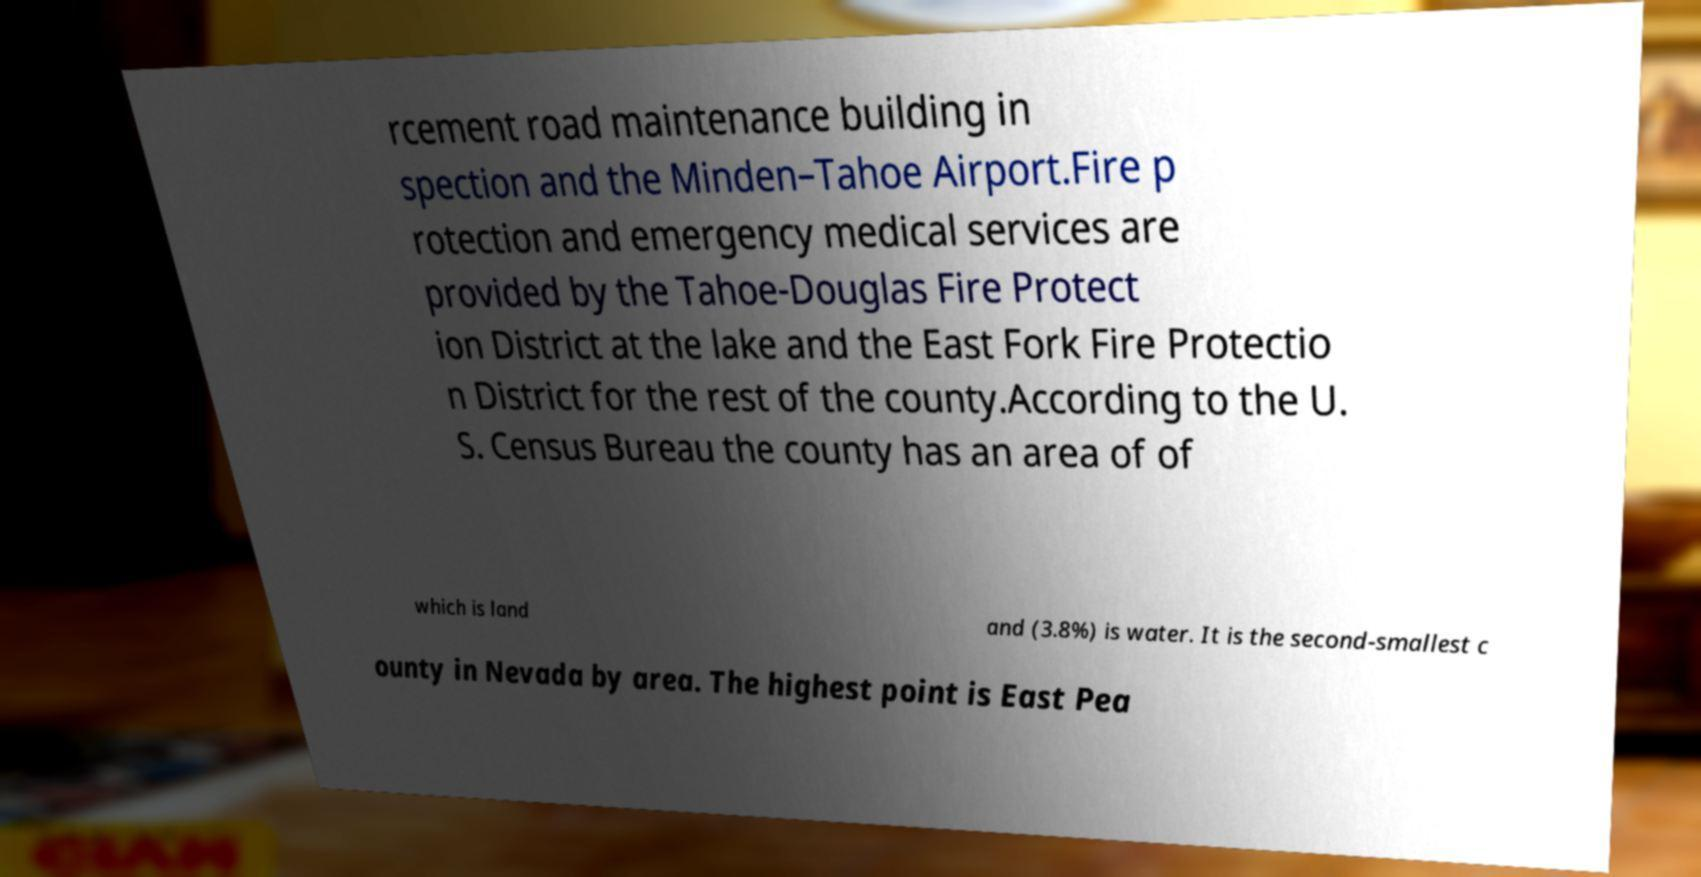There's text embedded in this image that I need extracted. Can you transcribe it verbatim? rcement road maintenance building in spection and the Minden–Tahoe Airport.Fire p rotection and emergency medical services are provided by the Tahoe-Douglas Fire Protect ion District at the lake and the East Fork Fire Protectio n District for the rest of the county.According to the U. S. Census Bureau the county has an area of of which is land and (3.8%) is water. It is the second-smallest c ounty in Nevada by area. The highest point is East Pea 